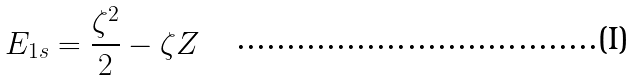Convert formula to latex. <formula><loc_0><loc_0><loc_500><loc_500>E _ { 1 s } = \frac { \zeta ^ { 2 } } { 2 } - \zeta Z</formula> 